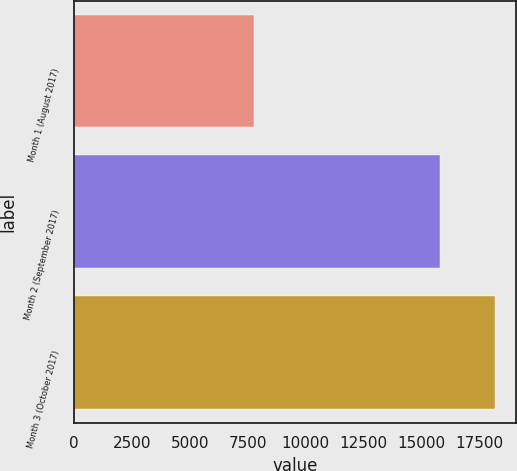Convert chart. <chart><loc_0><loc_0><loc_500><loc_500><bar_chart><fcel>Month 1 (August 2017)<fcel>Month 2 (September 2017)<fcel>Month 3 (October 2017)<nl><fcel>7779<fcel>15788<fcel>18200<nl></chart> 